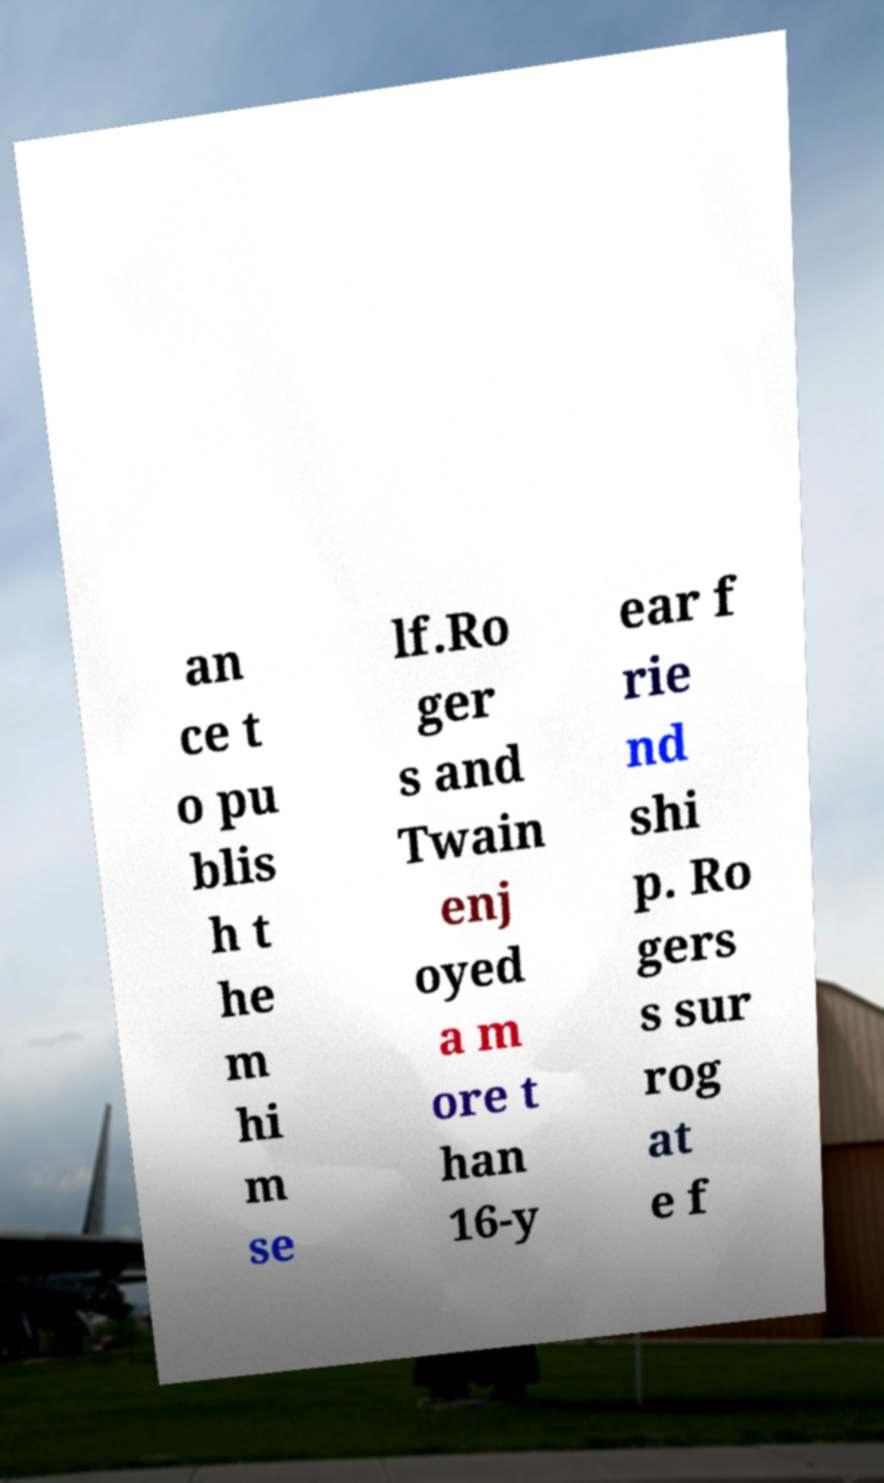Could you extract and type out the text from this image? an ce t o pu blis h t he m hi m se lf.Ro ger s and Twain enj oyed a m ore t han 16-y ear f rie nd shi p. Ro gers s sur rog at e f 